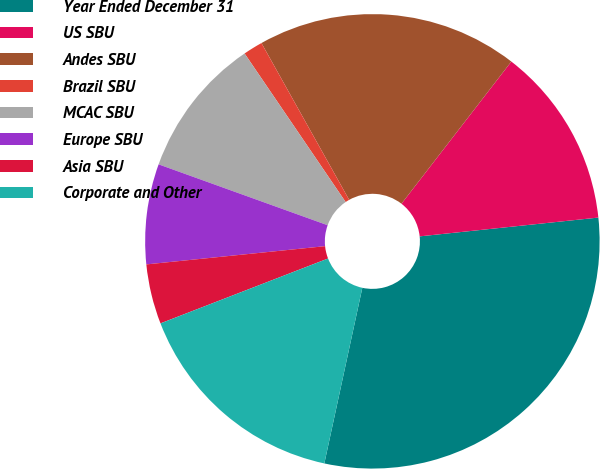Convert chart. <chart><loc_0><loc_0><loc_500><loc_500><pie_chart><fcel>Year Ended December 31<fcel>US SBU<fcel>Andes SBU<fcel>Brazil SBU<fcel>MCAC SBU<fcel>Europe SBU<fcel>Asia SBU<fcel>Corporate and Other<nl><fcel>30.06%<fcel>12.86%<fcel>18.59%<fcel>1.39%<fcel>9.99%<fcel>7.12%<fcel>4.26%<fcel>15.73%<nl></chart> 